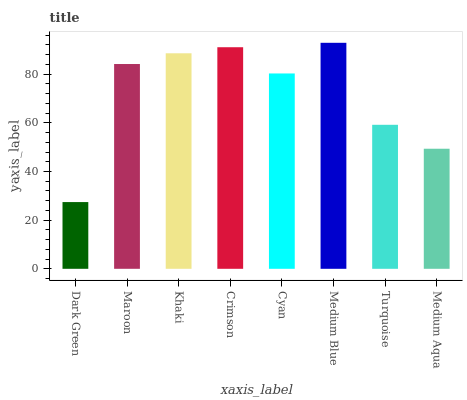Is Dark Green the minimum?
Answer yes or no. Yes. Is Medium Blue the maximum?
Answer yes or no. Yes. Is Maroon the minimum?
Answer yes or no. No. Is Maroon the maximum?
Answer yes or no. No. Is Maroon greater than Dark Green?
Answer yes or no. Yes. Is Dark Green less than Maroon?
Answer yes or no. Yes. Is Dark Green greater than Maroon?
Answer yes or no. No. Is Maroon less than Dark Green?
Answer yes or no. No. Is Maroon the high median?
Answer yes or no. Yes. Is Cyan the low median?
Answer yes or no. Yes. Is Medium Aqua the high median?
Answer yes or no. No. Is Turquoise the low median?
Answer yes or no. No. 